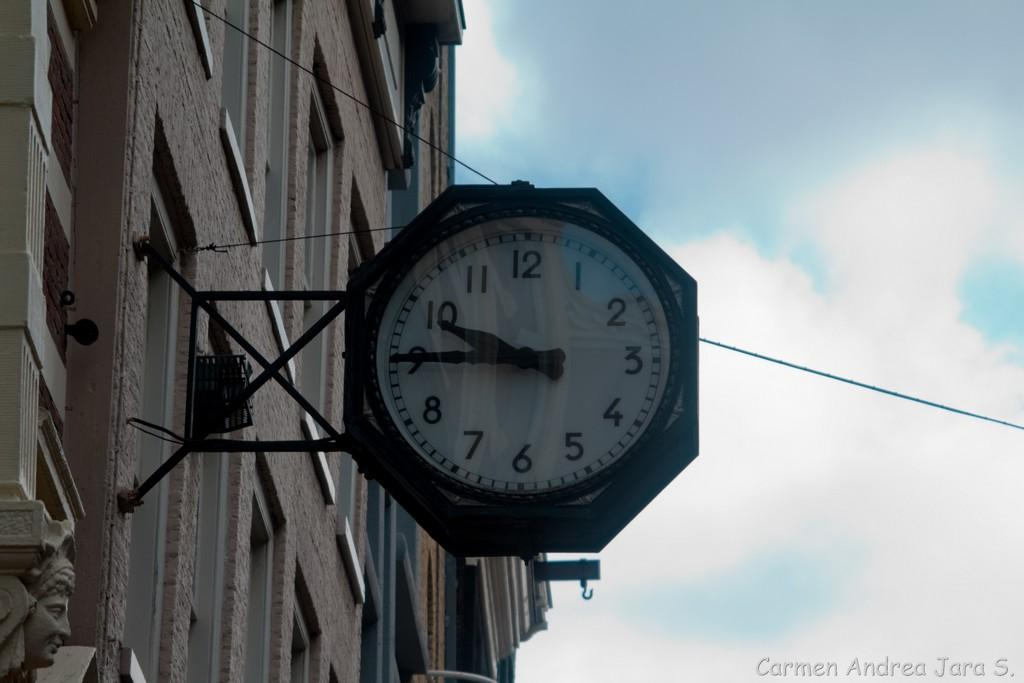<image>
Relay a brief, clear account of the picture shown. A photograph taken by Andrea Jara S. shows a clock on a building. 